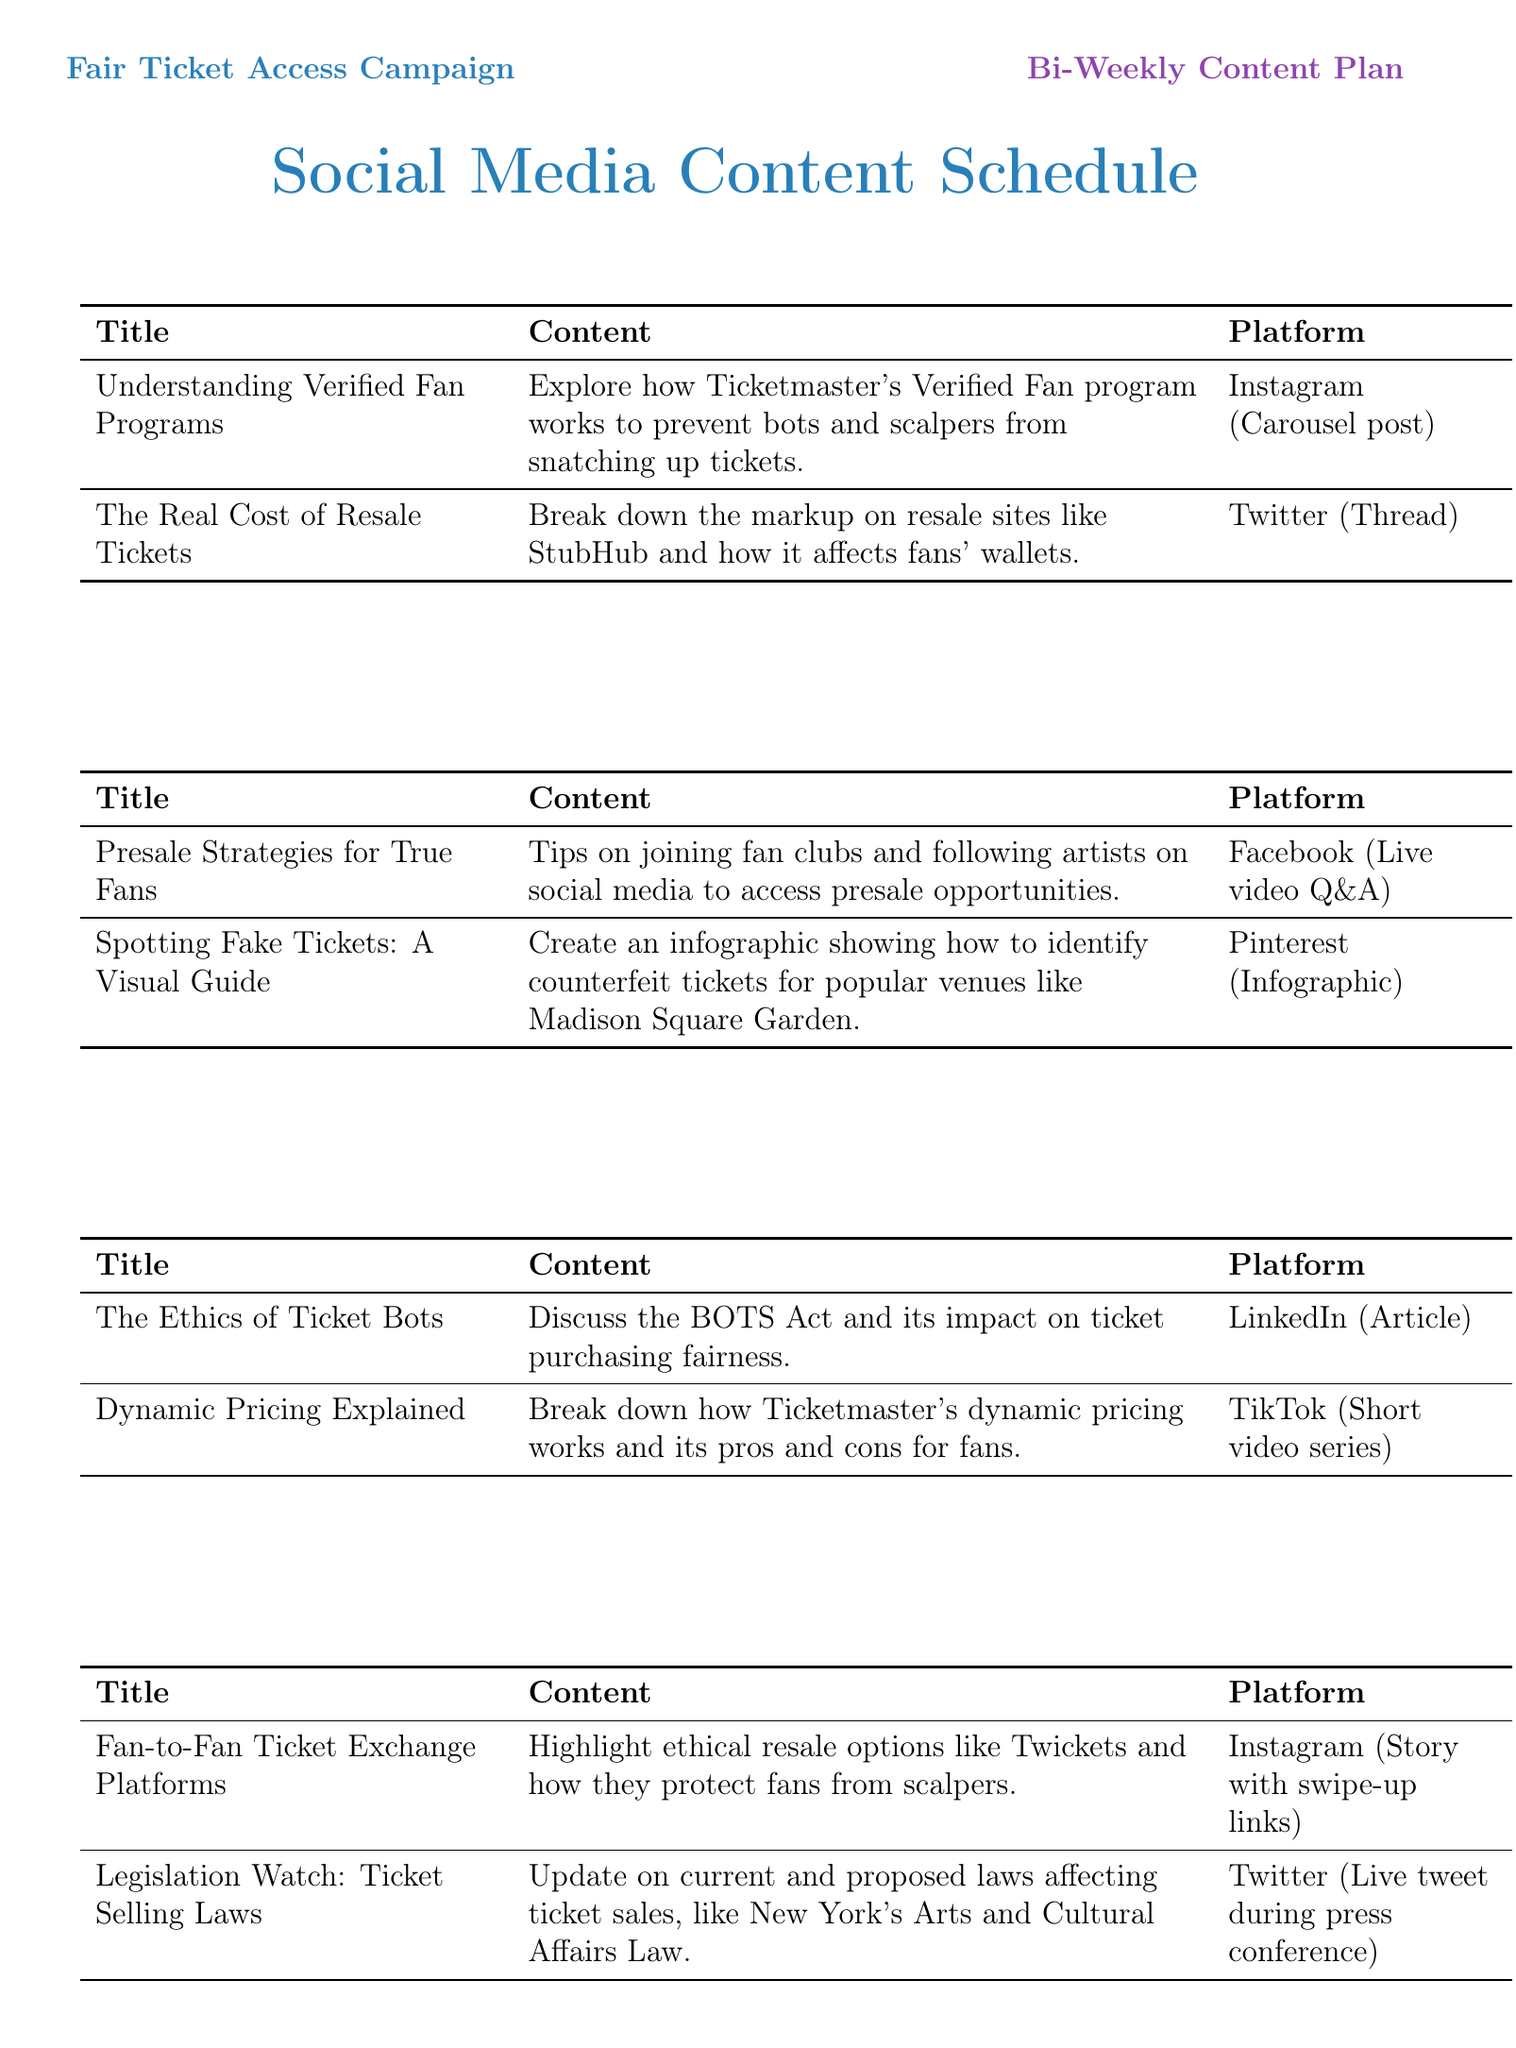What is the title of the first post? The title of the first post is the first entry under week one of the schedule.
Answer: Understanding Verified Fan Programs Which platform features the post about presale strategies? The platform for the presale strategies post can be found under week two of the schedule.
Answer: Facebook How many weeks are included in the content plan? The number of weeks is counted from week one through week six listed in the schedule.
Answer: 6 What type of content is used for the post on spotting fake tickets? The type of content refers to the format specified for that post in week two.
Answer: Infographic What is the main focus of the post under week three? The main focus can be determined by reviewing the titles of the posts listed under week three.
Answer: Ticket Bots Which week discusses the ethics of ticket bots? This can be identified by the header for week three in the schedule.
Answer: Week 3 What is the content format for the post on queue etiquette? The content format is mentioned alongside the title in week five.
Answer: Shareable graphic 